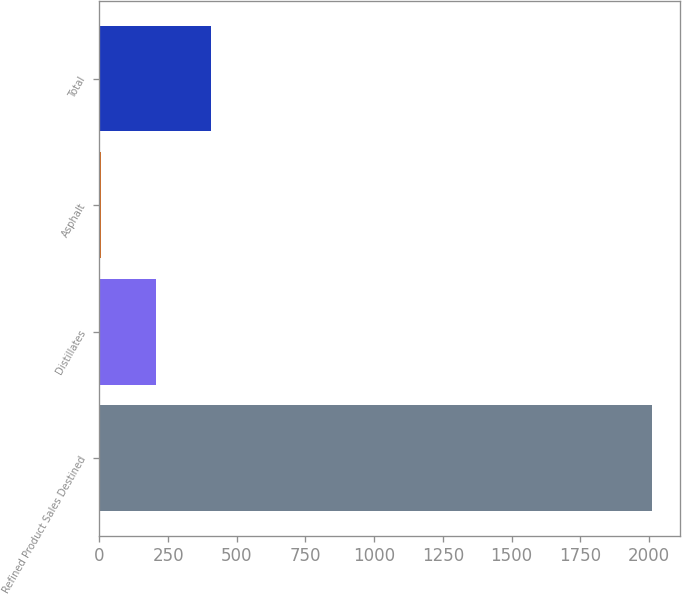<chart> <loc_0><loc_0><loc_500><loc_500><bar_chart><fcel>Refined Product Sales Destined<fcel>Distillates<fcel>Asphalt<fcel>Total<nl><fcel>2013<fcel>206.7<fcel>6<fcel>407.4<nl></chart> 